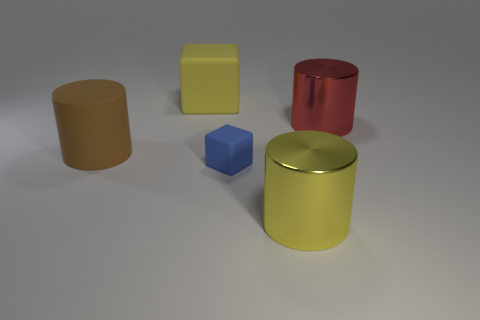There is a matte cube that is the same size as the yellow cylinder; what is its color?
Provide a succinct answer. Yellow. What number of big blue cubes are there?
Your response must be concise. 0. Is the material of the object that is behind the red cylinder the same as the red thing?
Provide a succinct answer. No. What is the material of the thing that is behind the brown rubber thing and to the right of the big yellow rubber cube?
Your answer should be very brief. Metal. There is a cylinder that is the same color as the large block; what is its size?
Provide a succinct answer. Large. What material is the yellow object in front of the large yellow object behind the red object made of?
Offer a very short reply. Metal. There is a block left of the cube that is in front of the large yellow matte cube that is on the left side of the blue rubber object; what is its size?
Your answer should be very brief. Large. How many yellow objects are made of the same material as the yellow block?
Make the answer very short. 0. The big metallic cylinder on the left side of the large shiny cylinder that is behind the tiny blue matte cube is what color?
Give a very brief answer. Yellow. What number of objects are red matte objects or large cylinders that are right of the blue matte thing?
Your answer should be very brief. 2. 